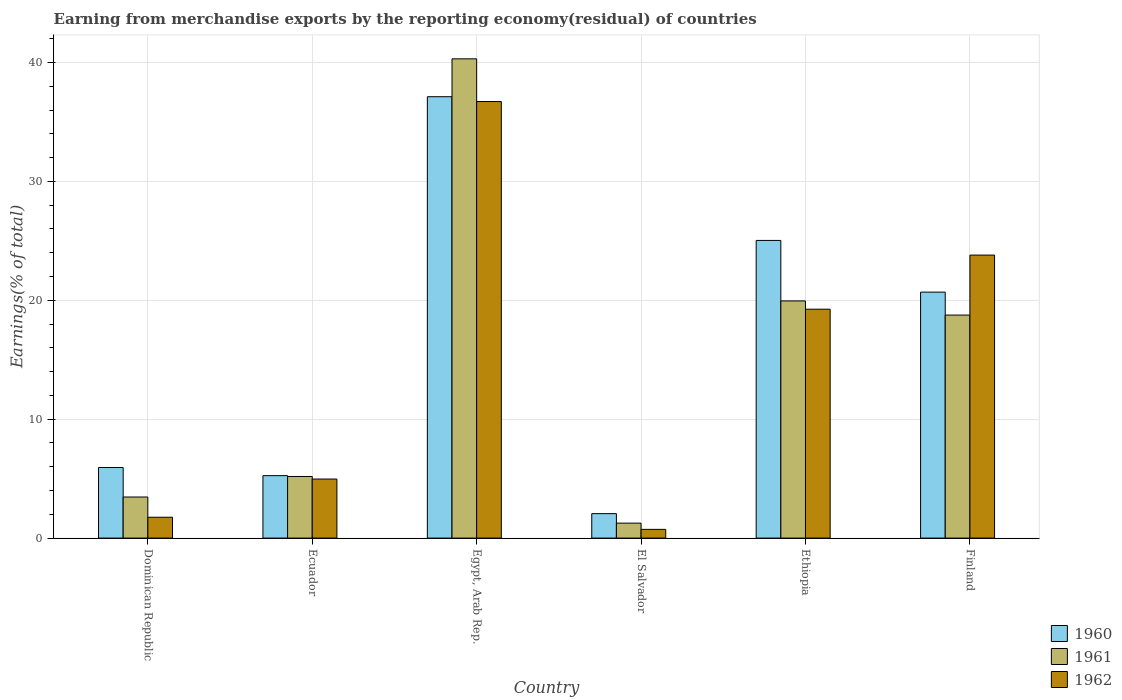How many different coloured bars are there?
Make the answer very short. 3. How many groups of bars are there?
Give a very brief answer. 6. How many bars are there on the 4th tick from the right?
Ensure brevity in your answer.  3. What is the label of the 5th group of bars from the left?
Your answer should be very brief. Ethiopia. What is the percentage of amount earned from merchandise exports in 1960 in Dominican Republic?
Provide a succinct answer. 5.94. Across all countries, what is the maximum percentage of amount earned from merchandise exports in 1961?
Offer a very short reply. 40.31. Across all countries, what is the minimum percentage of amount earned from merchandise exports in 1961?
Your answer should be compact. 1.26. In which country was the percentage of amount earned from merchandise exports in 1961 maximum?
Your response must be concise. Egypt, Arab Rep. In which country was the percentage of amount earned from merchandise exports in 1962 minimum?
Your response must be concise. El Salvador. What is the total percentage of amount earned from merchandise exports in 1961 in the graph?
Your response must be concise. 88.9. What is the difference between the percentage of amount earned from merchandise exports in 1961 in El Salvador and that in Finland?
Offer a terse response. -17.5. What is the difference between the percentage of amount earned from merchandise exports in 1962 in Ecuador and the percentage of amount earned from merchandise exports in 1960 in Dominican Republic?
Provide a short and direct response. -0.97. What is the average percentage of amount earned from merchandise exports in 1961 per country?
Offer a very short reply. 14.82. What is the difference between the percentage of amount earned from merchandise exports of/in 1961 and percentage of amount earned from merchandise exports of/in 1960 in Dominican Republic?
Provide a short and direct response. -2.48. In how many countries, is the percentage of amount earned from merchandise exports in 1960 greater than 8 %?
Ensure brevity in your answer.  3. What is the ratio of the percentage of amount earned from merchandise exports in 1961 in El Salvador to that in Finland?
Your answer should be very brief. 0.07. Is the difference between the percentage of amount earned from merchandise exports in 1961 in Egypt, Arab Rep. and Finland greater than the difference between the percentage of amount earned from merchandise exports in 1960 in Egypt, Arab Rep. and Finland?
Your response must be concise. Yes. What is the difference between the highest and the second highest percentage of amount earned from merchandise exports in 1960?
Ensure brevity in your answer.  4.35. What is the difference between the highest and the lowest percentage of amount earned from merchandise exports in 1960?
Your response must be concise. 35.06. In how many countries, is the percentage of amount earned from merchandise exports in 1961 greater than the average percentage of amount earned from merchandise exports in 1961 taken over all countries?
Make the answer very short. 3. What does the 2nd bar from the left in Ethiopia represents?
Give a very brief answer. 1961. How many bars are there?
Your response must be concise. 18. How many countries are there in the graph?
Keep it short and to the point. 6. What is the difference between two consecutive major ticks on the Y-axis?
Provide a succinct answer. 10. Does the graph contain any zero values?
Provide a short and direct response. No. What is the title of the graph?
Provide a succinct answer. Earning from merchandise exports by the reporting economy(residual) of countries. Does "1971" appear as one of the legend labels in the graph?
Ensure brevity in your answer.  No. What is the label or title of the Y-axis?
Give a very brief answer. Earnings(% of total). What is the Earnings(% of total) in 1960 in Dominican Republic?
Offer a terse response. 5.94. What is the Earnings(% of total) of 1961 in Dominican Republic?
Ensure brevity in your answer.  3.46. What is the Earnings(% of total) of 1962 in Dominican Republic?
Ensure brevity in your answer.  1.75. What is the Earnings(% of total) in 1960 in Ecuador?
Offer a very short reply. 5.25. What is the Earnings(% of total) in 1961 in Ecuador?
Your response must be concise. 5.18. What is the Earnings(% of total) in 1962 in Ecuador?
Make the answer very short. 4.97. What is the Earnings(% of total) of 1960 in Egypt, Arab Rep.?
Your answer should be very brief. 37.12. What is the Earnings(% of total) in 1961 in Egypt, Arab Rep.?
Provide a succinct answer. 40.31. What is the Earnings(% of total) of 1962 in Egypt, Arab Rep.?
Offer a very short reply. 36.71. What is the Earnings(% of total) in 1960 in El Salvador?
Keep it short and to the point. 2.06. What is the Earnings(% of total) in 1961 in El Salvador?
Your answer should be compact. 1.26. What is the Earnings(% of total) in 1962 in El Salvador?
Your response must be concise. 0.73. What is the Earnings(% of total) in 1960 in Ethiopia?
Provide a short and direct response. 25.03. What is the Earnings(% of total) of 1961 in Ethiopia?
Make the answer very short. 19.95. What is the Earnings(% of total) of 1962 in Ethiopia?
Provide a short and direct response. 19.25. What is the Earnings(% of total) in 1960 in Finland?
Make the answer very short. 20.69. What is the Earnings(% of total) of 1961 in Finland?
Give a very brief answer. 18.76. What is the Earnings(% of total) in 1962 in Finland?
Your answer should be compact. 23.8. Across all countries, what is the maximum Earnings(% of total) in 1960?
Offer a terse response. 37.12. Across all countries, what is the maximum Earnings(% of total) of 1961?
Make the answer very short. 40.31. Across all countries, what is the maximum Earnings(% of total) in 1962?
Your response must be concise. 36.71. Across all countries, what is the minimum Earnings(% of total) in 1960?
Make the answer very short. 2.06. Across all countries, what is the minimum Earnings(% of total) of 1961?
Your answer should be very brief. 1.26. Across all countries, what is the minimum Earnings(% of total) of 1962?
Keep it short and to the point. 0.73. What is the total Earnings(% of total) of 1960 in the graph?
Your answer should be compact. 96.09. What is the total Earnings(% of total) of 1961 in the graph?
Your answer should be compact. 88.9. What is the total Earnings(% of total) of 1962 in the graph?
Offer a terse response. 87.22. What is the difference between the Earnings(% of total) in 1960 in Dominican Republic and that in Ecuador?
Make the answer very short. 0.69. What is the difference between the Earnings(% of total) of 1961 in Dominican Republic and that in Ecuador?
Your answer should be compact. -1.73. What is the difference between the Earnings(% of total) in 1962 in Dominican Republic and that in Ecuador?
Keep it short and to the point. -3.21. What is the difference between the Earnings(% of total) of 1960 in Dominican Republic and that in Egypt, Arab Rep.?
Provide a succinct answer. -31.18. What is the difference between the Earnings(% of total) of 1961 in Dominican Republic and that in Egypt, Arab Rep.?
Keep it short and to the point. -36.85. What is the difference between the Earnings(% of total) in 1962 in Dominican Republic and that in Egypt, Arab Rep.?
Your response must be concise. -34.96. What is the difference between the Earnings(% of total) of 1960 in Dominican Republic and that in El Salvador?
Offer a terse response. 3.88. What is the difference between the Earnings(% of total) of 1961 in Dominican Republic and that in El Salvador?
Your answer should be very brief. 2.2. What is the difference between the Earnings(% of total) of 1962 in Dominican Republic and that in El Salvador?
Offer a very short reply. 1.02. What is the difference between the Earnings(% of total) in 1960 in Dominican Republic and that in Ethiopia?
Give a very brief answer. -19.1. What is the difference between the Earnings(% of total) in 1961 in Dominican Republic and that in Ethiopia?
Keep it short and to the point. -16.49. What is the difference between the Earnings(% of total) in 1962 in Dominican Republic and that in Ethiopia?
Keep it short and to the point. -17.5. What is the difference between the Earnings(% of total) in 1960 in Dominican Republic and that in Finland?
Your response must be concise. -14.75. What is the difference between the Earnings(% of total) in 1961 in Dominican Republic and that in Finland?
Offer a terse response. -15.3. What is the difference between the Earnings(% of total) in 1962 in Dominican Republic and that in Finland?
Offer a terse response. -22.05. What is the difference between the Earnings(% of total) in 1960 in Ecuador and that in Egypt, Arab Rep.?
Offer a terse response. -31.87. What is the difference between the Earnings(% of total) of 1961 in Ecuador and that in Egypt, Arab Rep.?
Provide a short and direct response. -35.12. What is the difference between the Earnings(% of total) of 1962 in Ecuador and that in Egypt, Arab Rep.?
Your response must be concise. -31.75. What is the difference between the Earnings(% of total) of 1960 in Ecuador and that in El Salvador?
Ensure brevity in your answer.  3.2. What is the difference between the Earnings(% of total) of 1961 in Ecuador and that in El Salvador?
Offer a terse response. 3.92. What is the difference between the Earnings(% of total) of 1962 in Ecuador and that in El Salvador?
Offer a very short reply. 4.23. What is the difference between the Earnings(% of total) of 1960 in Ecuador and that in Ethiopia?
Give a very brief answer. -19.78. What is the difference between the Earnings(% of total) in 1961 in Ecuador and that in Ethiopia?
Offer a very short reply. -14.77. What is the difference between the Earnings(% of total) in 1962 in Ecuador and that in Ethiopia?
Give a very brief answer. -14.28. What is the difference between the Earnings(% of total) in 1960 in Ecuador and that in Finland?
Offer a terse response. -15.43. What is the difference between the Earnings(% of total) of 1961 in Ecuador and that in Finland?
Make the answer very short. -13.57. What is the difference between the Earnings(% of total) of 1962 in Ecuador and that in Finland?
Ensure brevity in your answer.  -18.84. What is the difference between the Earnings(% of total) in 1960 in Egypt, Arab Rep. and that in El Salvador?
Provide a short and direct response. 35.06. What is the difference between the Earnings(% of total) in 1961 in Egypt, Arab Rep. and that in El Salvador?
Your answer should be compact. 39.05. What is the difference between the Earnings(% of total) in 1962 in Egypt, Arab Rep. and that in El Salvador?
Give a very brief answer. 35.98. What is the difference between the Earnings(% of total) in 1960 in Egypt, Arab Rep. and that in Ethiopia?
Provide a succinct answer. 12.09. What is the difference between the Earnings(% of total) in 1961 in Egypt, Arab Rep. and that in Ethiopia?
Provide a short and direct response. 20.36. What is the difference between the Earnings(% of total) in 1962 in Egypt, Arab Rep. and that in Ethiopia?
Give a very brief answer. 17.46. What is the difference between the Earnings(% of total) in 1960 in Egypt, Arab Rep. and that in Finland?
Your response must be concise. 16.43. What is the difference between the Earnings(% of total) of 1961 in Egypt, Arab Rep. and that in Finland?
Provide a short and direct response. 21.55. What is the difference between the Earnings(% of total) of 1962 in Egypt, Arab Rep. and that in Finland?
Your response must be concise. 12.91. What is the difference between the Earnings(% of total) in 1960 in El Salvador and that in Ethiopia?
Keep it short and to the point. -22.98. What is the difference between the Earnings(% of total) in 1961 in El Salvador and that in Ethiopia?
Make the answer very short. -18.69. What is the difference between the Earnings(% of total) in 1962 in El Salvador and that in Ethiopia?
Offer a terse response. -18.52. What is the difference between the Earnings(% of total) in 1960 in El Salvador and that in Finland?
Your answer should be very brief. -18.63. What is the difference between the Earnings(% of total) of 1961 in El Salvador and that in Finland?
Your response must be concise. -17.5. What is the difference between the Earnings(% of total) of 1962 in El Salvador and that in Finland?
Provide a short and direct response. -23.07. What is the difference between the Earnings(% of total) of 1960 in Ethiopia and that in Finland?
Offer a very short reply. 4.35. What is the difference between the Earnings(% of total) in 1961 in Ethiopia and that in Finland?
Provide a short and direct response. 1.19. What is the difference between the Earnings(% of total) of 1962 in Ethiopia and that in Finland?
Offer a very short reply. -4.55. What is the difference between the Earnings(% of total) of 1960 in Dominican Republic and the Earnings(% of total) of 1961 in Ecuador?
Your answer should be very brief. 0.76. What is the difference between the Earnings(% of total) in 1960 in Dominican Republic and the Earnings(% of total) in 1962 in Ecuador?
Make the answer very short. 0.97. What is the difference between the Earnings(% of total) in 1961 in Dominican Republic and the Earnings(% of total) in 1962 in Ecuador?
Your response must be concise. -1.51. What is the difference between the Earnings(% of total) of 1960 in Dominican Republic and the Earnings(% of total) of 1961 in Egypt, Arab Rep.?
Make the answer very short. -34.37. What is the difference between the Earnings(% of total) of 1960 in Dominican Republic and the Earnings(% of total) of 1962 in Egypt, Arab Rep.?
Your response must be concise. -30.78. What is the difference between the Earnings(% of total) in 1961 in Dominican Republic and the Earnings(% of total) in 1962 in Egypt, Arab Rep.?
Your answer should be compact. -33.26. What is the difference between the Earnings(% of total) of 1960 in Dominican Republic and the Earnings(% of total) of 1961 in El Salvador?
Your answer should be compact. 4.68. What is the difference between the Earnings(% of total) of 1960 in Dominican Republic and the Earnings(% of total) of 1962 in El Salvador?
Your answer should be very brief. 5.2. What is the difference between the Earnings(% of total) in 1961 in Dominican Republic and the Earnings(% of total) in 1962 in El Salvador?
Provide a short and direct response. 2.72. What is the difference between the Earnings(% of total) of 1960 in Dominican Republic and the Earnings(% of total) of 1961 in Ethiopia?
Keep it short and to the point. -14.01. What is the difference between the Earnings(% of total) in 1960 in Dominican Republic and the Earnings(% of total) in 1962 in Ethiopia?
Your answer should be very brief. -13.31. What is the difference between the Earnings(% of total) of 1961 in Dominican Republic and the Earnings(% of total) of 1962 in Ethiopia?
Offer a terse response. -15.79. What is the difference between the Earnings(% of total) in 1960 in Dominican Republic and the Earnings(% of total) in 1961 in Finland?
Your answer should be compact. -12.82. What is the difference between the Earnings(% of total) in 1960 in Dominican Republic and the Earnings(% of total) in 1962 in Finland?
Your answer should be compact. -17.86. What is the difference between the Earnings(% of total) in 1961 in Dominican Republic and the Earnings(% of total) in 1962 in Finland?
Give a very brief answer. -20.35. What is the difference between the Earnings(% of total) in 1960 in Ecuador and the Earnings(% of total) in 1961 in Egypt, Arab Rep.?
Offer a terse response. -35.05. What is the difference between the Earnings(% of total) of 1960 in Ecuador and the Earnings(% of total) of 1962 in Egypt, Arab Rep.?
Your answer should be very brief. -31.46. What is the difference between the Earnings(% of total) in 1961 in Ecuador and the Earnings(% of total) in 1962 in Egypt, Arab Rep.?
Give a very brief answer. -31.53. What is the difference between the Earnings(% of total) in 1960 in Ecuador and the Earnings(% of total) in 1961 in El Salvador?
Provide a short and direct response. 3.99. What is the difference between the Earnings(% of total) of 1960 in Ecuador and the Earnings(% of total) of 1962 in El Salvador?
Provide a short and direct response. 4.52. What is the difference between the Earnings(% of total) in 1961 in Ecuador and the Earnings(% of total) in 1962 in El Salvador?
Give a very brief answer. 4.45. What is the difference between the Earnings(% of total) of 1960 in Ecuador and the Earnings(% of total) of 1961 in Ethiopia?
Your answer should be compact. -14.69. What is the difference between the Earnings(% of total) of 1960 in Ecuador and the Earnings(% of total) of 1962 in Ethiopia?
Make the answer very short. -14. What is the difference between the Earnings(% of total) in 1961 in Ecuador and the Earnings(% of total) in 1962 in Ethiopia?
Provide a succinct answer. -14.07. What is the difference between the Earnings(% of total) of 1960 in Ecuador and the Earnings(% of total) of 1961 in Finland?
Give a very brief answer. -13.5. What is the difference between the Earnings(% of total) in 1960 in Ecuador and the Earnings(% of total) in 1962 in Finland?
Your answer should be compact. -18.55. What is the difference between the Earnings(% of total) of 1961 in Ecuador and the Earnings(% of total) of 1962 in Finland?
Offer a terse response. -18.62. What is the difference between the Earnings(% of total) in 1960 in Egypt, Arab Rep. and the Earnings(% of total) in 1961 in El Salvador?
Ensure brevity in your answer.  35.86. What is the difference between the Earnings(% of total) in 1960 in Egypt, Arab Rep. and the Earnings(% of total) in 1962 in El Salvador?
Make the answer very short. 36.39. What is the difference between the Earnings(% of total) in 1961 in Egypt, Arab Rep. and the Earnings(% of total) in 1962 in El Salvador?
Offer a very short reply. 39.57. What is the difference between the Earnings(% of total) of 1960 in Egypt, Arab Rep. and the Earnings(% of total) of 1961 in Ethiopia?
Your answer should be very brief. 17.17. What is the difference between the Earnings(% of total) in 1960 in Egypt, Arab Rep. and the Earnings(% of total) in 1962 in Ethiopia?
Keep it short and to the point. 17.87. What is the difference between the Earnings(% of total) of 1961 in Egypt, Arab Rep. and the Earnings(% of total) of 1962 in Ethiopia?
Offer a very short reply. 21.06. What is the difference between the Earnings(% of total) in 1960 in Egypt, Arab Rep. and the Earnings(% of total) in 1961 in Finland?
Offer a terse response. 18.36. What is the difference between the Earnings(% of total) in 1960 in Egypt, Arab Rep. and the Earnings(% of total) in 1962 in Finland?
Ensure brevity in your answer.  13.32. What is the difference between the Earnings(% of total) of 1961 in Egypt, Arab Rep. and the Earnings(% of total) of 1962 in Finland?
Your response must be concise. 16.5. What is the difference between the Earnings(% of total) of 1960 in El Salvador and the Earnings(% of total) of 1961 in Ethiopia?
Give a very brief answer. -17.89. What is the difference between the Earnings(% of total) in 1960 in El Salvador and the Earnings(% of total) in 1962 in Ethiopia?
Keep it short and to the point. -17.19. What is the difference between the Earnings(% of total) in 1961 in El Salvador and the Earnings(% of total) in 1962 in Ethiopia?
Provide a succinct answer. -17.99. What is the difference between the Earnings(% of total) of 1960 in El Salvador and the Earnings(% of total) of 1961 in Finland?
Ensure brevity in your answer.  -16.7. What is the difference between the Earnings(% of total) in 1960 in El Salvador and the Earnings(% of total) in 1962 in Finland?
Provide a succinct answer. -21.74. What is the difference between the Earnings(% of total) in 1961 in El Salvador and the Earnings(% of total) in 1962 in Finland?
Offer a terse response. -22.54. What is the difference between the Earnings(% of total) of 1960 in Ethiopia and the Earnings(% of total) of 1961 in Finland?
Your answer should be compact. 6.28. What is the difference between the Earnings(% of total) in 1960 in Ethiopia and the Earnings(% of total) in 1962 in Finland?
Make the answer very short. 1.23. What is the difference between the Earnings(% of total) in 1961 in Ethiopia and the Earnings(% of total) in 1962 in Finland?
Make the answer very short. -3.85. What is the average Earnings(% of total) in 1960 per country?
Offer a very short reply. 16.01. What is the average Earnings(% of total) in 1961 per country?
Keep it short and to the point. 14.82. What is the average Earnings(% of total) of 1962 per country?
Provide a short and direct response. 14.54. What is the difference between the Earnings(% of total) in 1960 and Earnings(% of total) in 1961 in Dominican Republic?
Provide a short and direct response. 2.48. What is the difference between the Earnings(% of total) in 1960 and Earnings(% of total) in 1962 in Dominican Republic?
Your answer should be very brief. 4.18. What is the difference between the Earnings(% of total) in 1961 and Earnings(% of total) in 1962 in Dominican Republic?
Provide a short and direct response. 1.7. What is the difference between the Earnings(% of total) of 1960 and Earnings(% of total) of 1961 in Ecuador?
Your answer should be very brief. 0.07. What is the difference between the Earnings(% of total) of 1960 and Earnings(% of total) of 1962 in Ecuador?
Offer a very short reply. 0.29. What is the difference between the Earnings(% of total) of 1961 and Earnings(% of total) of 1962 in Ecuador?
Give a very brief answer. 0.22. What is the difference between the Earnings(% of total) of 1960 and Earnings(% of total) of 1961 in Egypt, Arab Rep.?
Ensure brevity in your answer.  -3.18. What is the difference between the Earnings(% of total) in 1960 and Earnings(% of total) in 1962 in Egypt, Arab Rep.?
Keep it short and to the point. 0.41. What is the difference between the Earnings(% of total) of 1961 and Earnings(% of total) of 1962 in Egypt, Arab Rep.?
Offer a very short reply. 3.59. What is the difference between the Earnings(% of total) of 1960 and Earnings(% of total) of 1961 in El Salvador?
Make the answer very short. 0.8. What is the difference between the Earnings(% of total) of 1960 and Earnings(% of total) of 1962 in El Salvador?
Provide a short and direct response. 1.32. What is the difference between the Earnings(% of total) of 1961 and Earnings(% of total) of 1962 in El Salvador?
Provide a succinct answer. 0.52. What is the difference between the Earnings(% of total) of 1960 and Earnings(% of total) of 1961 in Ethiopia?
Give a very brief answer. 5.09. What is the difference between the Earnings(% of total) of 1960 and Earnings(% of total) of 1962 in Ethiopia?
Provide a succinct answer. 5.78. What is the difference between the Earnings(% of total) in 1961 and Earnings(% of total) in 1962 in Ethiopia?
Your answer should be compact. 0.7. What is the difference between the Earnings(% of total) in 1960 and Earnings(% of total) in 1961 in Finland?
Provide a short and direct response. 1.93. What is the difference between the Earnings(% of total) in 1960 and Earnings(% of total) in 1962 in Finland?
Your response must be concise. -3.11. What is the difference between the Earnings(% of total) in 1961 and Earnings(% of total) in 1962 in Finland?
Your answer should be compact. -5.04. What is the ratio of the Earnings(% of total) of 1960 in Dominican Republic to that in Ecuador?
Give a very brief answer. 1.13. What is the ratio of the Earnings(% of total) of 1961 in Dominican Republic to that in Ecuador?
Offer a very short reply. 0.67. What is the ratio of the Earnings(% of total) of 1962 in Dominican Republic to that in Ecuador?
Your answer should be compact. 0.35. What is the ratio of the Earnings(% of total) in 1960 in Dominican Republic to that in Egypt, Arab Rep.?
Your response must be concise. 0.16. What is the ratio of the Earnings(% of total) of 1961 in Dominican Republic to that in Egypt, Arab Rep.?
Give a very brief answer. 0.09. What is the ratio of the Earnings(% of total) in 1962 in Dominican Republic to that in Egypt, Arab Rep.?
Keep it short and to the point. 0.05. What is the ratio of the Earnings(% of total) of 1960 in Dominican Republic to that in El Salvador?
Your answer should be compact. 2.89. What is the ratio of the Earnings(% of total) of 1961 in Dominican Republic to that in El Salvador?
Offer a terse response. 2.75. What is the ratio of the Earnings(% of total) in 1962 in Dominican Republic to that in El Salvador?
Offer a very short reply. 2.39. What is the ratio of the Earnings(% of total) of 1960 in Dominican Republic to that in Ethiopia?
Keep it short and to the point. 0.24. What is the ratio of the Earnings(% of total) in 1961 in Dominican Republic to that in Ethiopia?
Provide a short and direct response. 0.17. What is the ratio of the Earnings(% of total) of 1962 in Dominican Republic to that in Ethiopia?
Provide a short and direct response. 0.09. What is the ratio of the Earnings(% of total) in 1960 in Dominican Republic to that in Finland?
Your answer should be very brief. 0.29. What is the ratio of the Earnings(% of total) of 1961 in Dominican Republic to that in Finland?
Ensure brevity in your answer.  0.18. What is the ratio of the Earnings(% of total) in 1962 in Dominican Republic to that in Finland?
Ensure brevity in your answer.  0.07. What is the ratio of the Earnings(% of total) in 1960 in Ecuador to that in Egypt, Arab Rep.?
Make the answer very short. 0.14. What is the ratio of the Earnings(% of total) in 1961 in Ecuador to that in Egypt, Arab Rep.?
Provide a succinct answer. 0.13. What is the ratio of the Earnings(% of total) in 1962 in Ecuador to that in Egypt, Arab Rep.?
Ensure brevity in your answer.  0.14. What is the ratio of the Earnings(% of total) in 1960 in Ecuador to that in El Salvador?
Ensure brevity in your answer.  2.55. What is the ratio of the Earnings(% of total) of 1961 in Ecuador to that in El Salvador?
Offer a terse response. 4.12. What is the ratio of the Earnings(% of total) in 1962 in Ecuador to that in El Salvador?
Your answer should be compact. 6.77. What is the ratio of the Earnings(% of total) of 1960 in Ecuador to that in Ethiopia?
Your response must be concise. 0.21. What is the ratio of the Earnings(% of total) in 1961 in Ecuador to that in Ethiopia?
Offer a very short reply. 0.26. What is the ratio of the Earnings(% of total) in 1962 in Ecuador to that in Ethiopia?
Keep it short and to the point. 0.26. What is the ratio of the Earnings(% of total) of 1960 in Ecuador to that in Finland?
Provide a short and direct response. 0.25. What is the ratio of the Earnings(% of total) of 1961 in Ecuador to that in Finland?
Offer a terse response. 0.28. What is the ratio of the Earnings(% of total) of 1962 in Ecuador to that in Finland?
Your answer should be very brief. 0.21. What is the ratio of the Earnings(% of total) of 1960 in Egypt, Arab Rep. to that in El Salvador?
Offer a very short reply. 18.05. What is the ratio of the Earnings(% of total) in 1961 in Egypt, Arab Rep. to that in El Salvador?
Your answer should be compact. 32.03. What is the ratio of the Earnings(% of total) in 1962 in Egypt, Arab Rep. to that in El Salvador?
Your answer should be very brief. 50.04. What is the ratio of the Earnings(% of total) in 1960 in Egypt, Arab Rep. to that in Ethiopia?
Provide a succinct answer. 1.48. What is the ratio of the Earnings(% of total) in 1961 in Egypt, Arab Rep. to that in Ethiopia?
Offer a terse response. 2.02. What is the ratio of the Earnings(% of total) in 1962 in Egypt, Arab Rep. to that in Ethiopia?
Offer a very short reply. 1.91. What is the ratio of the Earnings(% of total) of 1960 in Egypt, Arab Rep. to that in Finland?
Keep it short and to the point. 1.79. What is the ratio of the Earnings(% of total) in 1961 in Egypt, Arab Rep. to that in Finland?
Your response must be concise. 2.15. What is the ratio of the Earnings(% of total) of 1962 in Egypt, Arab Rep. to that in Finland?
Provide a short and direct response. 1.54. What is the ratio of the Earnings(% of total) of 1960 in El Salvador to that in Ethiopia?
Your answer should be compact. 0.08. What is the ratio of the Earnings(% of total) in 1961 in El Salvador to that in Ethiopia?
Offer a terse response. 0.06. What is the ratio of the Earnings(% of total) of 1962 in El Salvador to that in Ethiopia?
Your answer should be compact. 0.04. What is the ratio of the Earnings(% of total) in 1960 in El Salvador to that in Finland?
Give a very brief answer. 0.1. What is the ratio of the Earnings(% of total) in 1961 in El Salvador to that in Finland?
Your response must be concise. 0.07. What is the ratio of the Earnings(% of total) in 1962 in El Salvador to that in Finland?
Give a very brief answer. 0.03. What is the ratio of the Earnings(% of total) in 1960 in Ethiopia to that in Finland?
Your answer should be very brief. 1.21. What is the ratio of the Earnings(% of total) in 1961 in Ethiopia to that in Finland?
Make the answer very short. 1.06. What is the ratio of the Earnings(% of total) of 1962 in Ethiopia to that in Finland?
Your answer should be compact. 0.81. What is the difference between the highest and the second highest Earnings(% of total) of 1960?
Provide a short and direct response. 12.09. What is the difference between the highest and the second highest Earnings(% of total) in 1961?
Offer a very short reply. 20.36. What is the difference between the highest and the second highest Earnings(% of total) in 1962?
Keep it short and to the point. 12.91. What is the difference between the highest and the lowest Earnings(% of total) of 1960?
Your response must be concise. 35.06. What is the difference between the highest and the lowest Earnings(% of total) of 1961?
Provide a succinct answer. 39.05. What is the difference between the highest and the lowest Earnings(% of total) of 1962?
Offer a terse response. 35.98. 